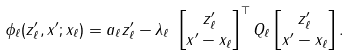<formula> <loc_0><loc_0><loc_500><loc_500>\phi _ { \ell } ( z _ { \ell } ^ { \prime } , x ^ { \prime } ; x _ { \ell } ) & = a _ { \ell } z _ { \ell } ^ { \prime } - \lambda _ { \ell } \ \begin{bmatrix} z _ { \ell } ^ { \prime } \\ x ^ { \prime } - x _ { \ell } \end{bmatrix} ^ { \top } Q _ { \ell } \begin{bmatrix} z _ { \ell } ^ { \prime } \\ x ^ { \prime } - x _ { \ell } \end{bmatrix} .</formula> 